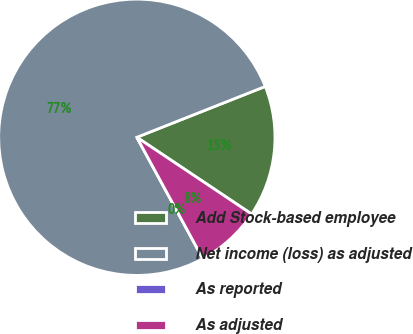Convert chart. <chart><loc_0><loc_0><loc_500><loc_500><pie_chart><fcel>Add Stock-based employee<fcel>Net income (loss) as adjusted<fcel>As reported<fcel>As adjusted<nl><fcel>15.38%<fcel>76.92%<fcel>0.0%<fcel>7.69%<nl></chart> 